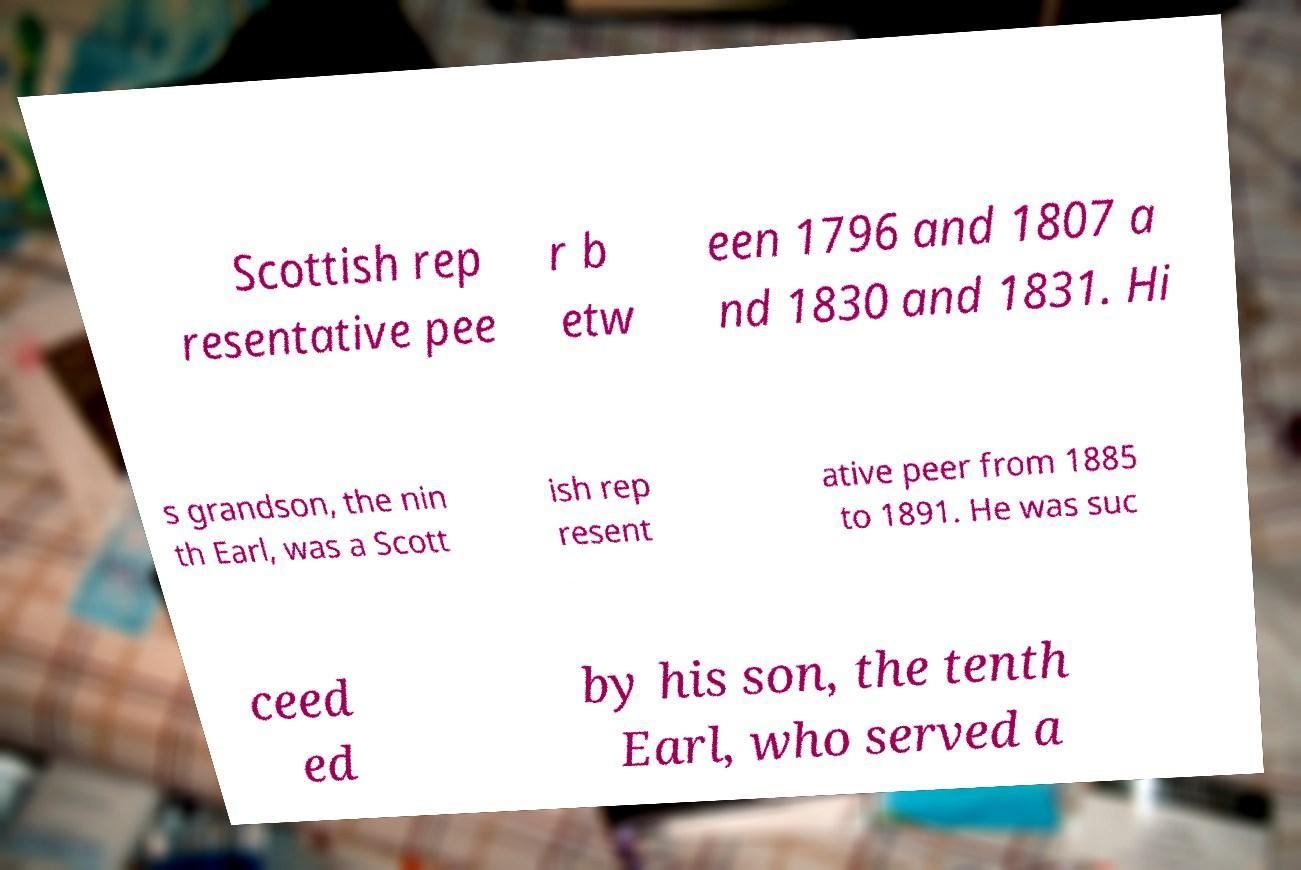Please identify and transcribe the text found in this image. Scottish rep resentative pee r b etw een 1796 and 1807 a nd 1830 and 1831. Hi s grandson, the nin th Earl, was a Scott ish rep resent ative peer from 1885 to 1891. He was suc ceed ed by his son, the tenth Earl, who served a 